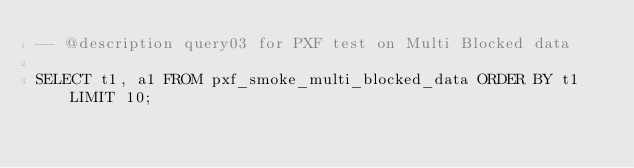<code> <loc_0><loc_0><loc_500><loc_500><_SQL_>-- @description query03 for PXF test on Multi Blocked data

SELECT t1, a1 FROM pxf_smoke_multi_blocked_data ORDER BY t1 LIMIT 10;</code> 